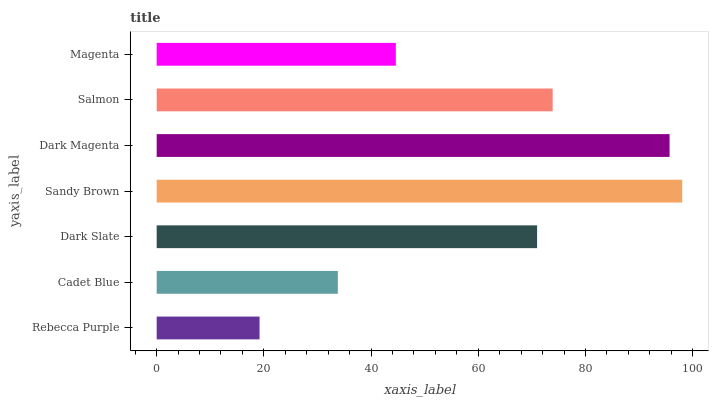Is Rebecca Purple the minimum?
Answer yes or no. Yes. Is Sandy Brown the maximum?
Answer yes or no. Yes. Is Cadet Blue the minimum?
Answer yes or no. No. Is Cadet Blue the maximum?
Answer yes or no. No. Is Cadet Blue greater than Rebecca Purple?
Answer yes or no. Yes. Is Rebecca Purple less than Cadet Blue?
Answer yes or no. Yes. Is Rebecca Purple greater than Cadet Blue?
Answer yes or no. No. Is Cadet Blue less than Rebecca Purple?
Answer yes or no. No. Is Dark Slate the high median?
Answer yes or no. Yes. Is Dark Slate the low median?
Answer yes or no. Yes. Is Sandy Brown the high median?
Answer yes or no. No. Is Rebecca Purple the low median?
Answer yes or no. No. 